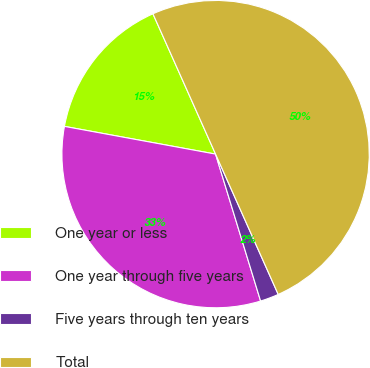Convert chart to OTSL. <chart><loc_0><loc_0><loc_500><loc_500><pie_chart><fcel>One year or less<fcel>One year through five years<fcel>Five years through ten years<fcel>Total<nl><fcel>15.43%<fcel>32.62%<fcel>1.95%<fcel>50.0%<nl></chart> 